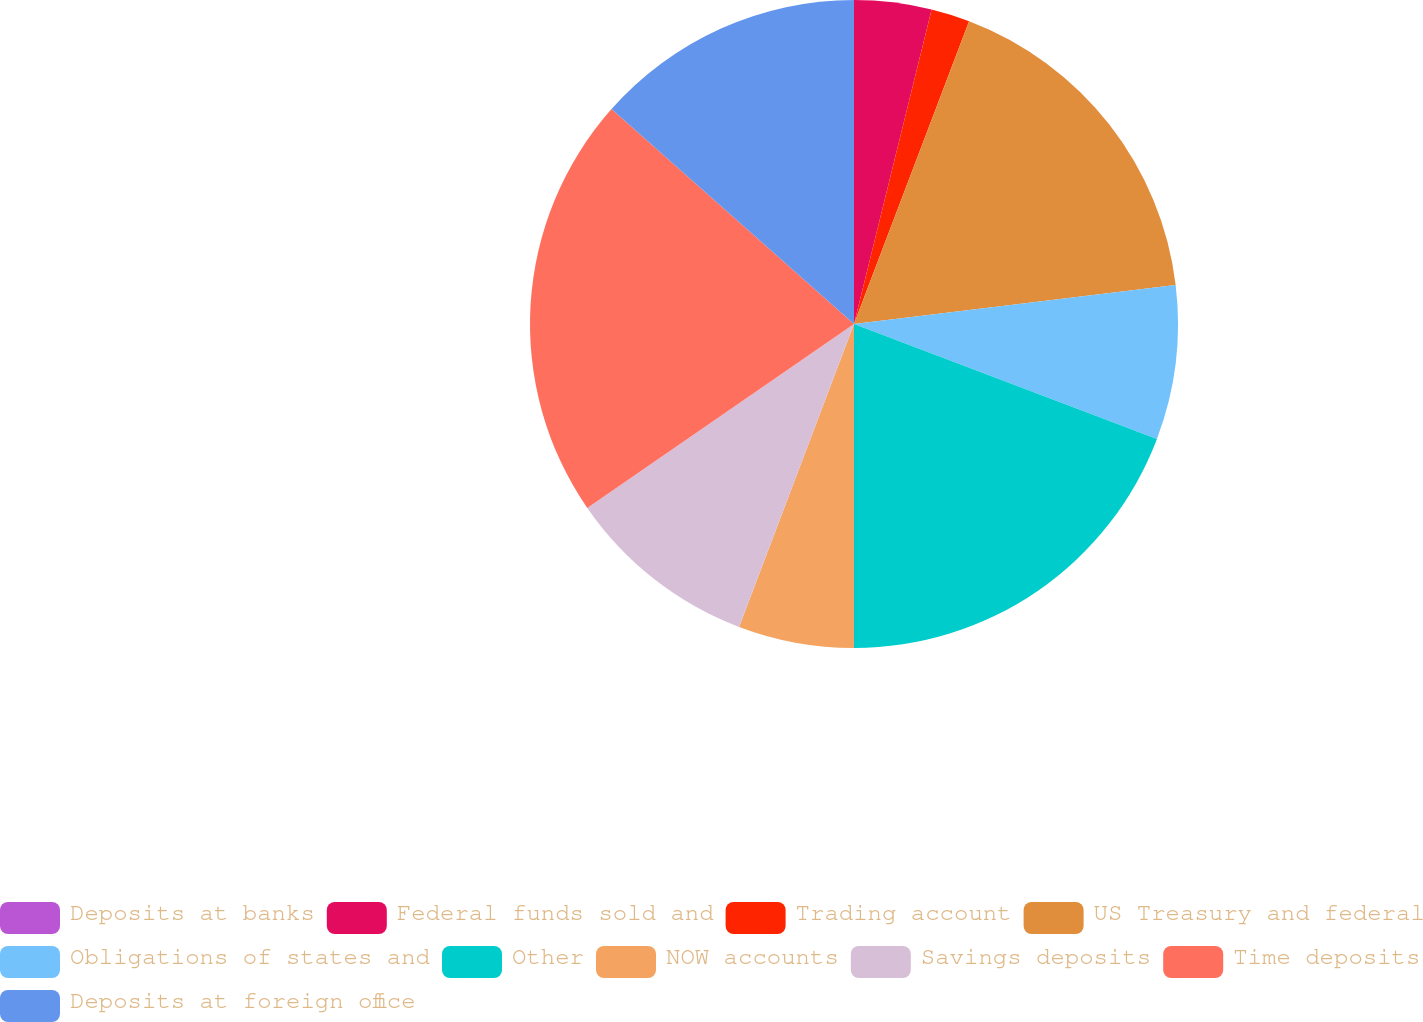Convert chart. <chart><loc_0><loc_0><loc_500><loc_500><pie_chart><fcel>Deposits at banks<fcel>Federal funds sold and<fcel>Trading account<fcel>US Treasury and federal<fcel>Obligations of states and<fcel>Other<fcel>NOW accounts<fcel>Savings deposits<fcel>Time deposits<fcel>Deposits at foreign office<nl><fcel>0.0%<fcel>3.85%<fcel>1.93%<fcel>17.3%<fcel>7.69%<fcel>19.23%<fcel>5.77%<fcel>9.62%<fcel>21.15%<fcel>13.46%<nl></chart> 